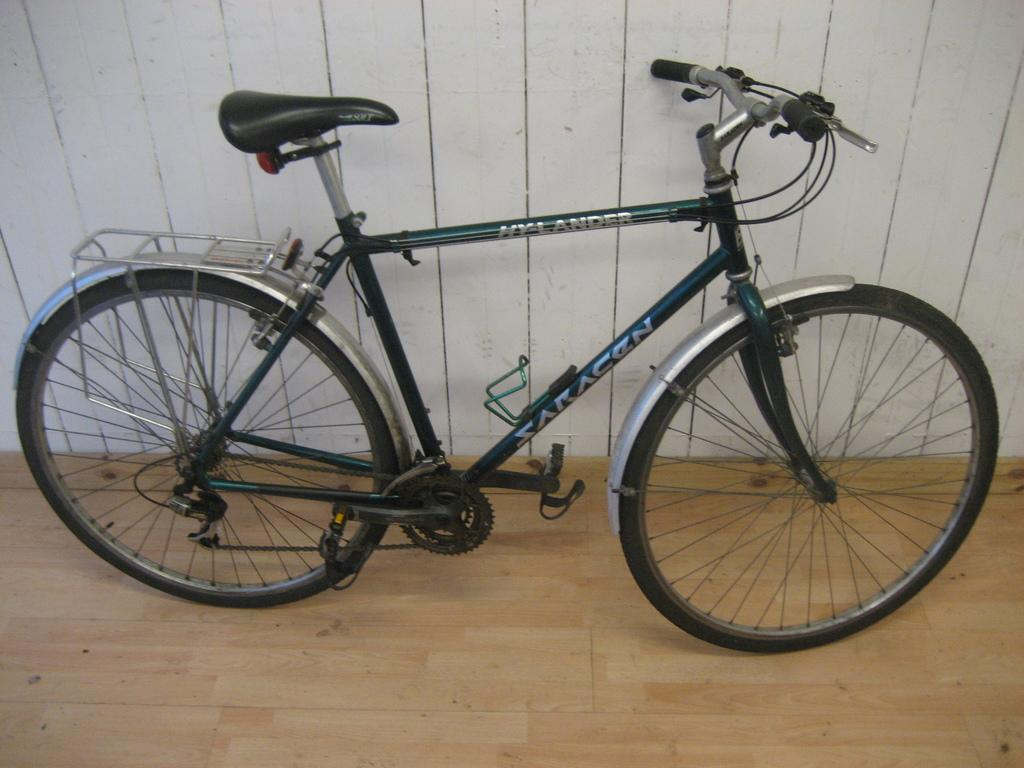What is the main object in the picture? There is a bicycle in the picture. What colors can be seen on the bicycle? The bicycle is green and silver in color. How is the bicycle positioned in relation to the wall? The bicycle is leaned against a white wall. What type of space unit can be seen in the image? There is no space unit present in the image; it features a bicycle leaned against a white wall. What kind of lace is used to decorate the bicycle in the image? There is no lace present on the bicycle in the image. 